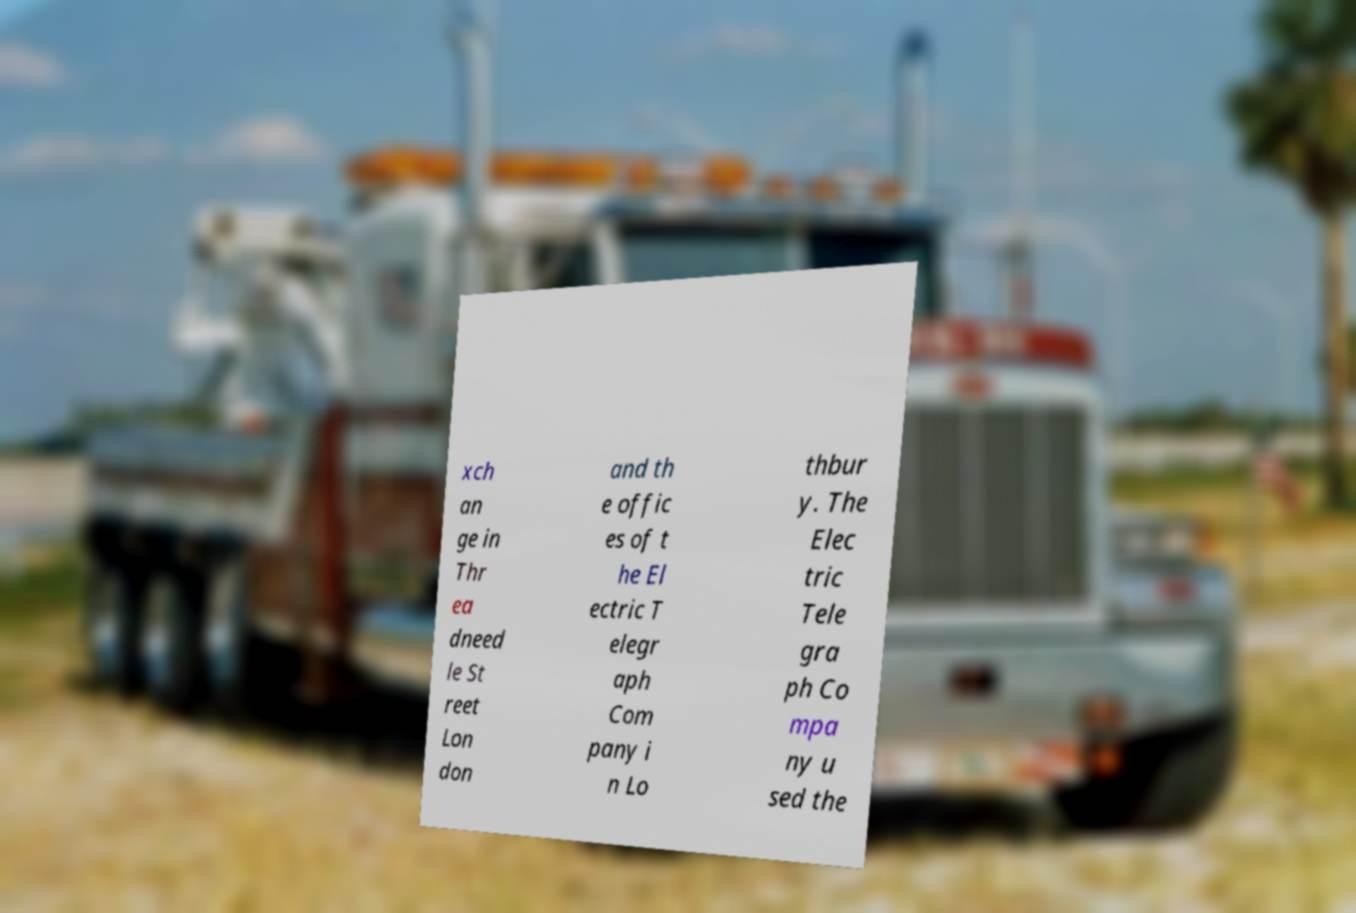Please identify and transcribe the text found in this image. xch an ge in Thr ea dneed le St reet Lon don and th e offic es of t he El ectric T elegr aph Com pany i n Lo thbur y. The Elec tric Tele gra ph Co mpa ny u sed the 